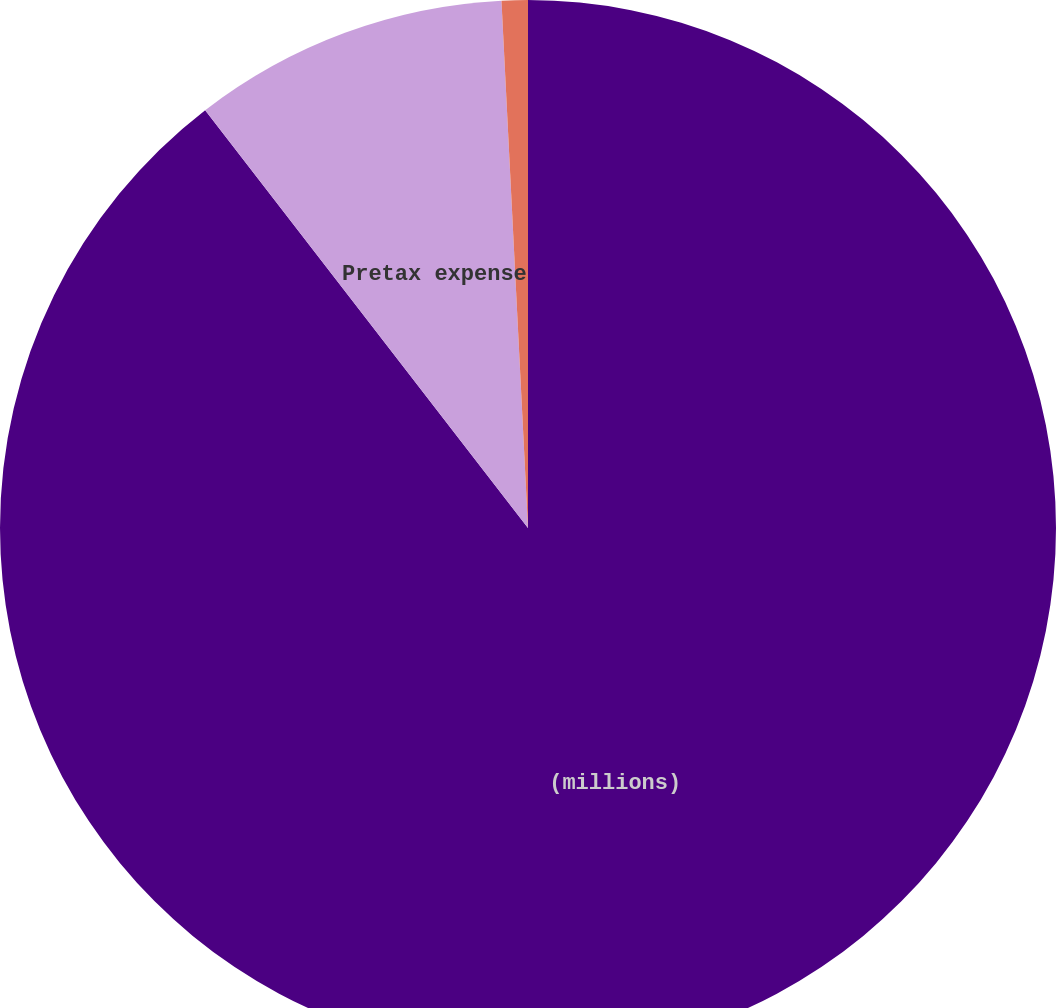Convert chart. <chart><loc_0><loc_0><loc_500><loc_500><pie_chart><fcel>(millions)<fcel>Pretax expense<fcel>Tax benefit<nl><fcel>89.53%<fcel>9.67%<fcel>0.8%<nl></chart> 